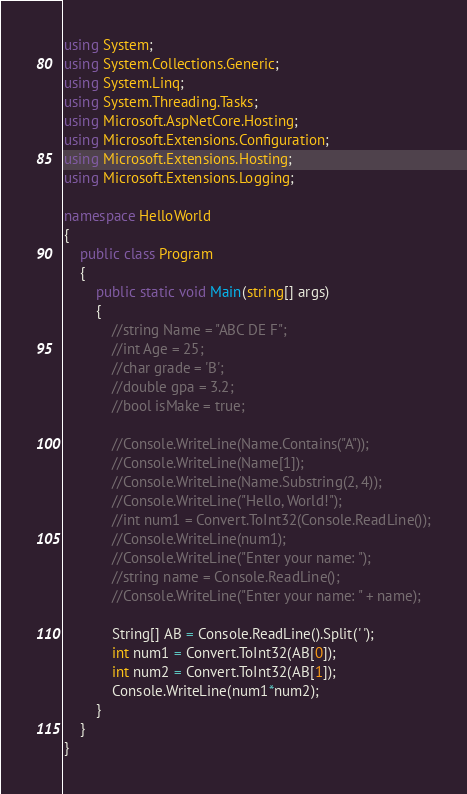Convert code to text. <code><loc_0><loc_0><loc_500><loc_500><_C#_>using System;
using System.Collections.Generic;
using System.Linq;
using System.Threading.Tasks;
using Microsoft.AspNetCore.Hosting;
using Microsoft.Extensions.Configuration;
using Microsoft.Extensions.Hosting;
using Microsoft.Extensions.Logging;

namespace HelloWorld
{
    public class Program
    {
        public static void Main(string[] args)
        {
            //string Name = "ABC DE F";
            //int Age = 25;
            //char grade = 'B';
            //double gpa = 3.2;
            //bool isMake = true;

            //Console.WriteLine(Name.Contains("A"));
            //Console.WriteLine(Name[1]);
            //Console.WriteLine(Name.Substring(2, 4));
            //Console.WriteLine("Hello, World!");
            //int num1 = Convert.ToInt32(Console.ReadLine());
            //Console.WriteLine(num1);
            //Console.WriteLine("Enter your name: ");
            //string name = Console.ReadLine();
            //Console.WriteLine("Enter your name: " + name);

            String[] AB = Console.ReadLine().Split(' ');
            int num1 = Convert.ToInt32(AB[0]);
            int num2 = Convert.ToInt32(AB[1]);
            Console.WriteLine(num1*num2);
        }
    }
}</code> 